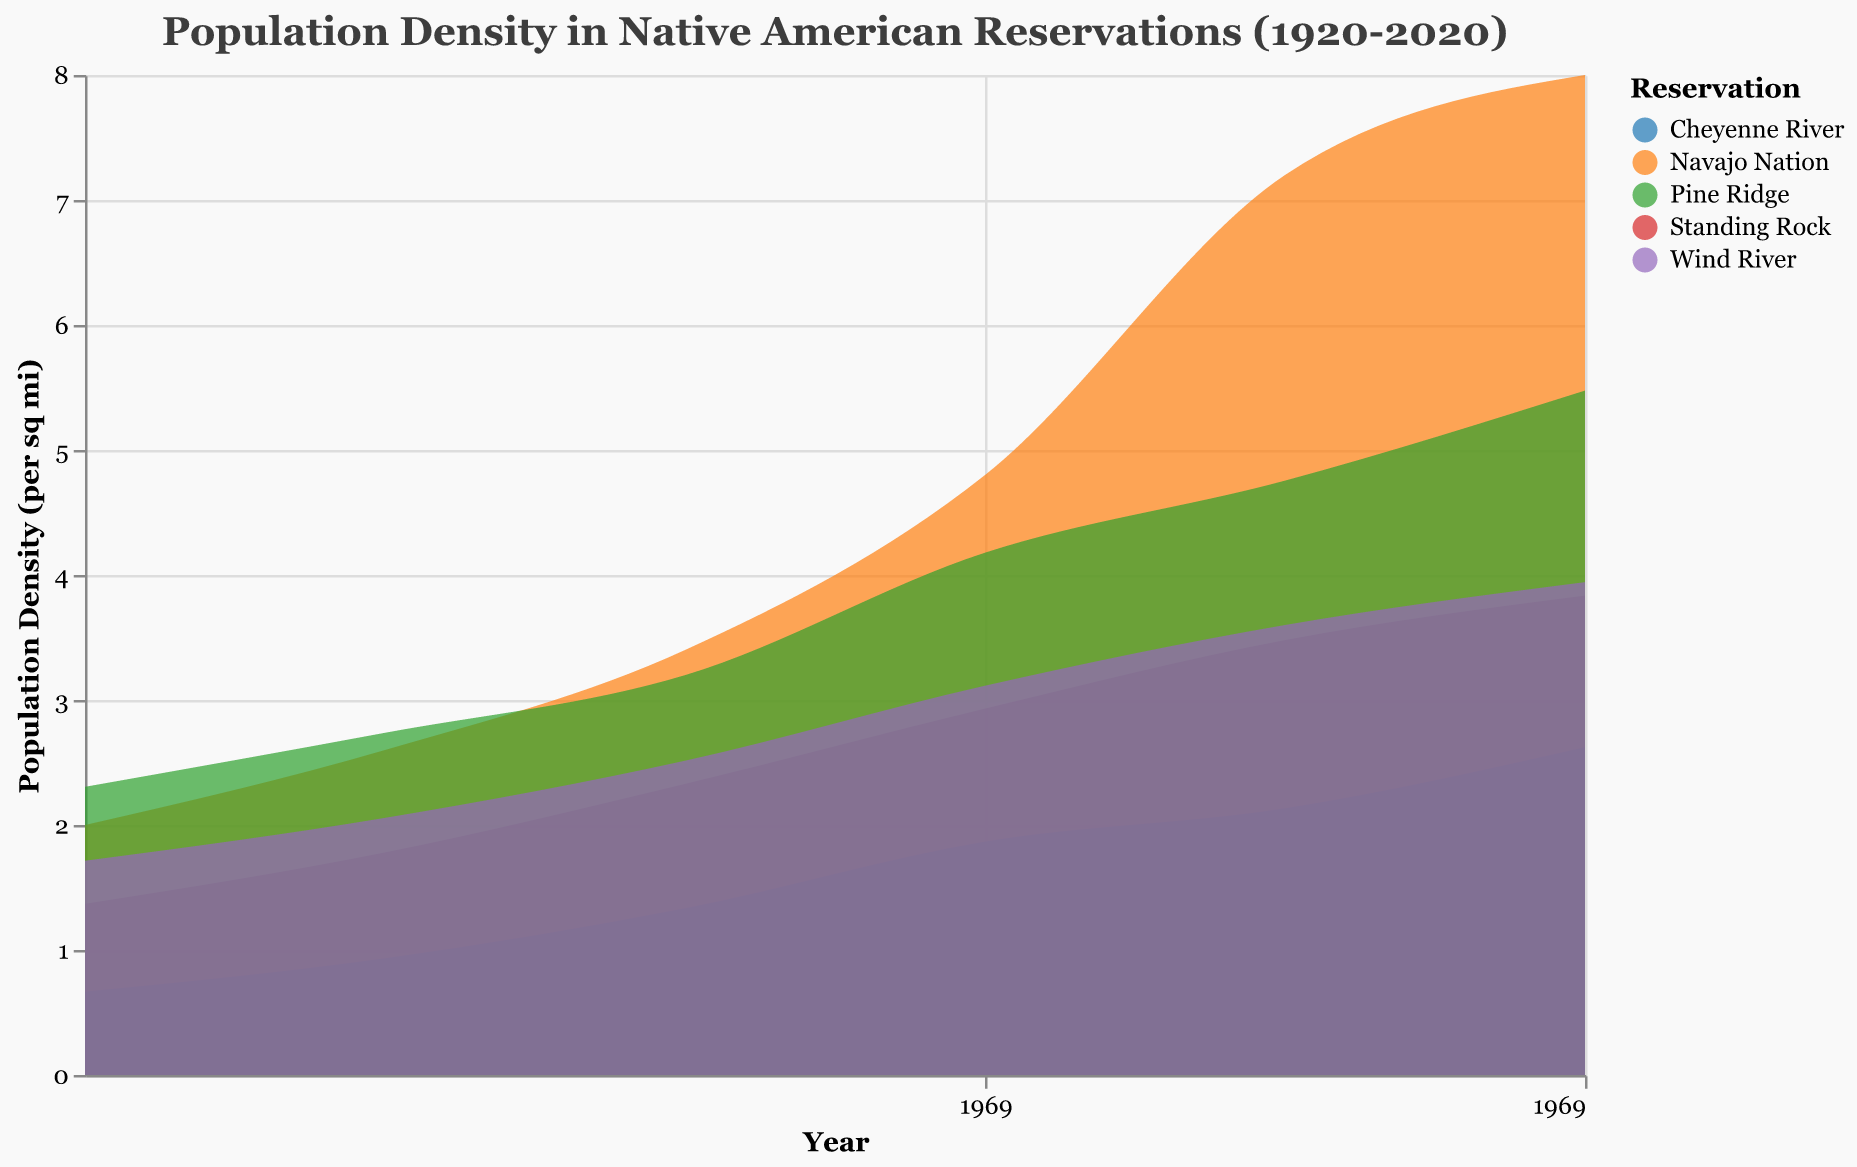What is the title of the figure? The title is displayed at the top of the figure in the largest and boldest font. It reads "Population Density in Native American Reservations (1920-2020)"
Answer: Population Density in Native American Reservations (1920-2020) How does the density of the Navajo Nation change from 1920 to 2020? The density of the Navajo Nation increases over time. By examining the plot, we see that the density curve for the Navajo Nation rises as the years progress due to an increase in population while the area remains constant.
Answer: It increases Which reservation had the lowest population density in 1940? By examining the density values in the year 1940 along the y-axis, Cheyenne River has the lowest density compared to other reservations.
Answer: Cheyenne River How many reservations are represented in the figure? The color legend shows different colors representing different reservations. By counting the entries in the legend, we can see there are five reservations.
Answer: Five Calculate the population density of Pine Ridge in 1980 and compare it to Wind River in the same year. Which is higher? In 1980, Pine Ridge has a population of 14,500 and an area of 3,470 sq mi, giving a density of 14,500 / 3,470 = ~4.18. Wind River has a population of 10,900 and an area of 3,500 sq mi, giving a density of 10,900 / 3,500 = ~3.11.
Answer: Pine Ridge is higher Which reservation has shown the most significant increase in density from 1920 to 2020? By visually comparing the density increase over the periods for each reservation, Navajo Nation shows the most significant increase. The density rises steeply compared to others.
Answer: Navajo Nation What is the population density of Wind River in 2020? In 2020, Wind River has a population of 13,800. Given the area is 3,500 sq mi as it remains constant, the density is calculated as 13,800 / 3,500 = ~3.94
Answer: ~3.94 In what year does Cheyenne River see a notable increase in its population density? By examining the changes in the density curve for Cheyenne River, a notable increase can be seen around the year 2020.
Answer: 2020 What trend is observed in the population density of Standing Rock from 1960 to 2000? The density of Standing Rock shows an increasing trend from 1960 to 2000. This is evident from the upward slope of the density curve.
Answer: Increasing trend How does the population density of Pine Ridge in 2000 compare to Standing Rock in 2000? In 2000, Pine Ridge shows a higher density compared to Standing Rock. The plot displays the density curve for Pine Ridge slightly above that of Standing Rock.
Answer: Pine Ridge is higher 